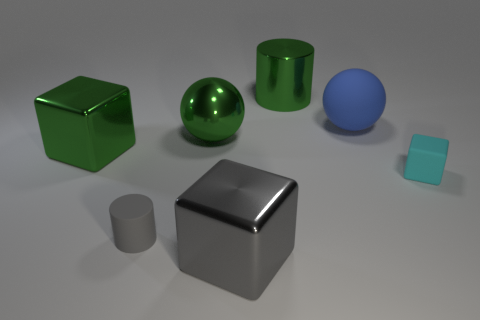How big is the metal block in front of the tiny object that is to the left of the large blue matte thing?
Offer a very short reply. Large. Is the number of big rubber objects that are to the left of the blue sphere the same as the number of blue matte things that are behind the rubber block?
Offer a very short reply. No. There is a cube that is made of the same material as the big blue ball; what color is it?
Give a very brief answer. Cyan. Is the big green cylinder made of the same material as the big sphere that is left of the matte sphere?
Provide a succinct answer. Yes. There is a block that is on the left side of the large metallic cylinder and to the right of the gray rubber object; what is its color?
Offer a terse response. Gray. How many cylinders are small things or large gray metallic objects?
Keep it short and to the point. 1. Does the gray metal object have the same shape as the big metal thing behind the large green ball?
Keep it short and to the point. No. What size is the green metal object that is both in front of the big cylinder and right of the big green metallic cube?
Offer a very short reply. Large. The big blue object is what shape?
Offer a terse response. Sphere. There is a small rubber thing that is right of the gray metallic cube; are there any gray cylinders that are in front of it?
Provide a succinct answer. Yes. 